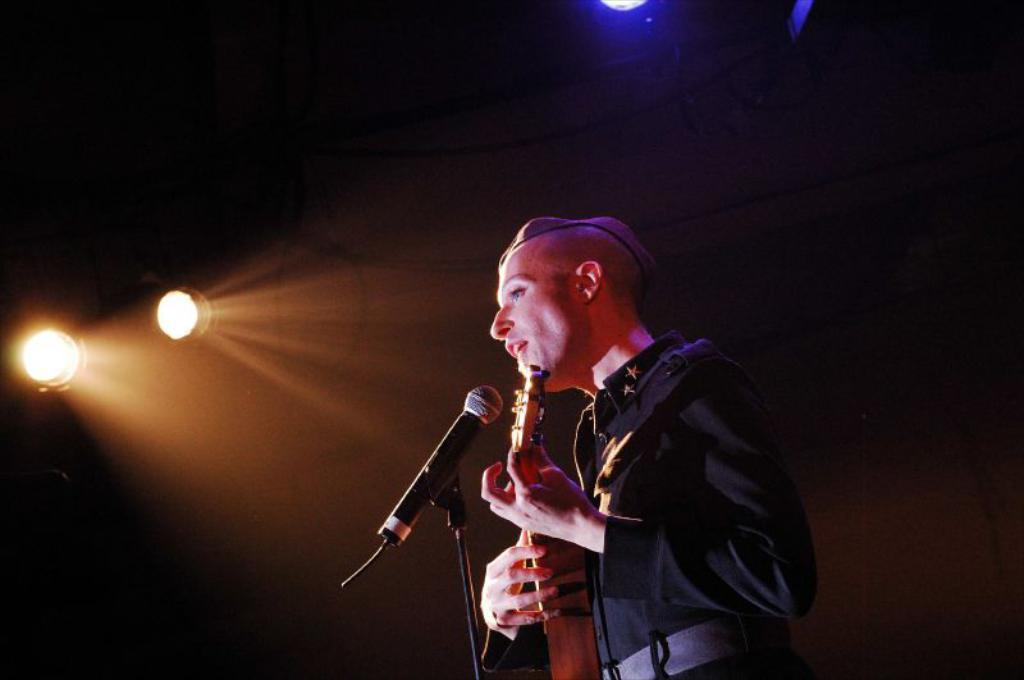What is the man in the image doing? The man is playing a guitar in the image. What object is the man using while playing the guitar? The man is using a microphone while playing the guitar. Can you describe the man's activity in the image? The man is playing the guitar and using a microphone, which suggests he might be performing or singing. What color are the man's eyes in the image? The provided facts do not mention the man's eyes, so we cannot determine their color from the image. 